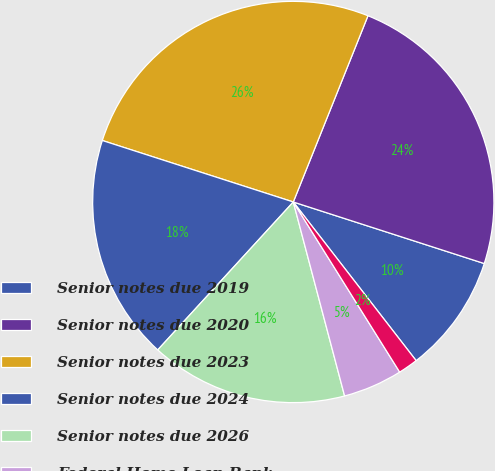Convert chart to OTSL. <chart><loc_0><loc_0><loc_500><loc_500><pie_chart><fcel>Senior notes due 2019<fcel>Senior notes due 2020<fcel>Senior notes due 2023<fcel>Senior notes due 2024<fcel>Senior notes due 2026<fcel>Federal Home Loan Bank<fcel>Repurchase agreements<nl><fcel>9.55%<fcel>23.89%<fcel>26.11%<fcel>18.15%<fcel>15.92%<fcel>4.78%<fcel>1.59%<nl></chart> 